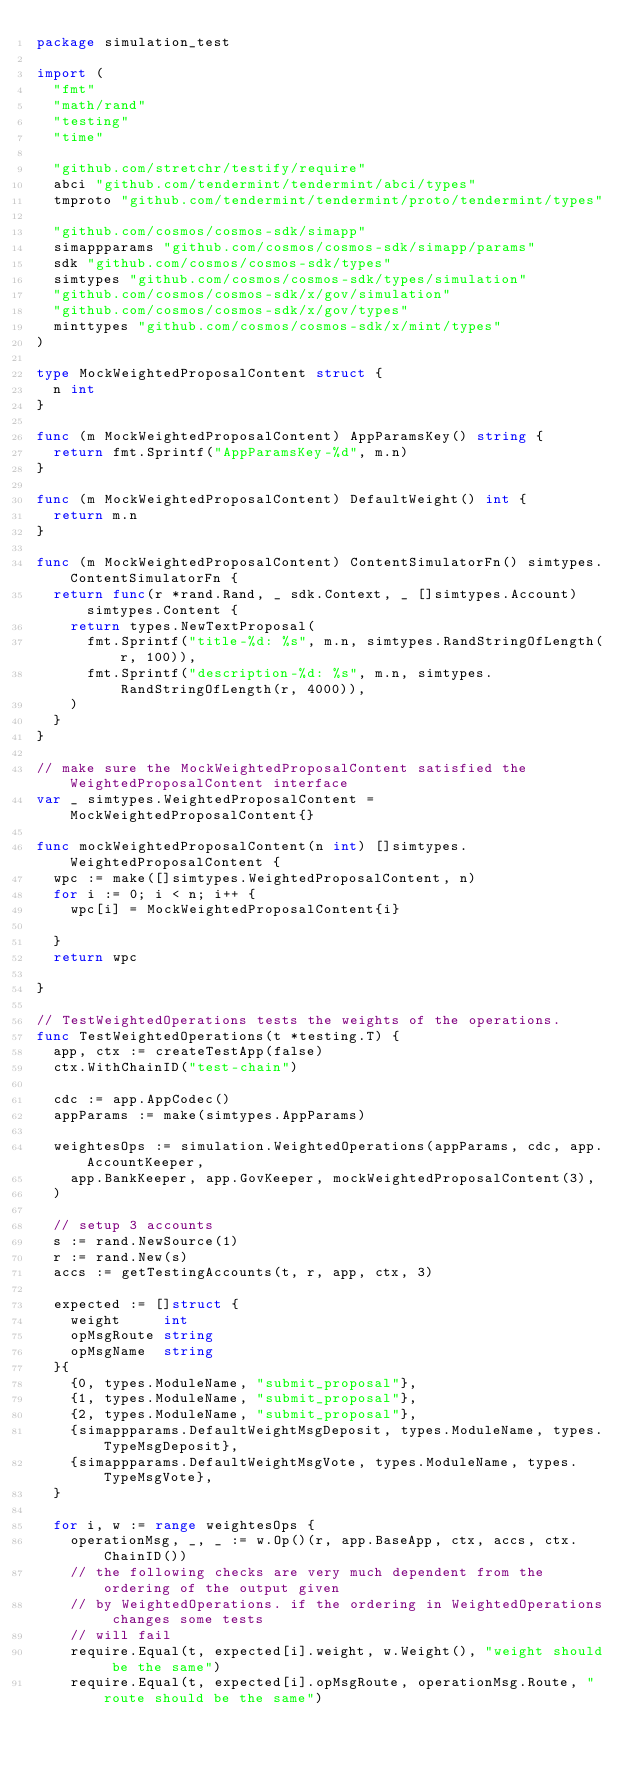<code> <loc_0><loc_0><loc_500><loc_500><_Go_>package simulation_test

import (
	"fmt"
	"math/rand"
	"testing"
	"time"

	"github.com/stretchr/testify/require"
	abci "github.com/tendermint/tendermint/abci/types"
	tmproto "github.com/tendermint/tendermint/proto/tendermint/types"

	"github.com/cosmos/cosmos-sdk/simapp"
	simappparams "github.com/cosmos/cosmos-sdk/simapp/params"
	sdk "github.com/cosmos/cosmos-sdk/types"
	simtypes "github.com/cosmos/cosmos-sdk/types/simulation"
	"github.com/cosmos/cosmos-sdk/x/gov/simulation"
	"github.com/cosmos/cosmos-sdk/x/gov/types"
	minttypes "github.com/cosmos/cosmos-sdk/x/mint/types"
)

type MockWeightedProposalContent struct {
	n int
}

func (m MockWeightedProposalContent) AppParamsKey() string {
	return fmt.Sprintf("AppParamsKey-%d", m.n)
}

func (m MockWeightedProposalContent) DefaultWeight() int {
	return m.n
}

func (m MockWeightedProposalContent) ContentSimulatorFn() simtypes.ContentSimulatorFn {
	return func(r *rand.Rand, _ sdk.Context, _ []simtypes.Account) simtypes.Content {
		return types.NewTextProposal(
			fmt.Sprintf("title-%d: %s", m.n, simtypes.RandStringOfLength(r, 100)),
			fmt.Sprintf("description-%d: %s", m.n, simtypes.RandStringOfLength(r, 4000)),
		)
	}
}

// make sure the MockWeightedProposalContent satisfied the WeightedProposalContent interface
var _ simtypes.WeightedProposalContent = MockWeightedProposalContent{}

func mockWeightedProposalContent(n int) []simtypes.WeightedProposalContent {
	wpc := make([]simtypes.WeightedProposalContent, n)
	for i := 0; i < n; i++ {
		wpc[i] = MockWeightedProposalContent{i}

	}
	return wpc

}

// TestWeightedOperations tests the weights of the operations.
func TestWeightedOperations(t *testing.T) {
	app, ctx := createTestApp(false)
	ctx.WithChainID("test-chain")

	cdc := app.AppCodec()
	appParams := make(simtypes.AppParams)

	weightesOps := simulation.WeightedOperations(appParams, cdc, app.AccountKeeper,
		app.BankKeeper, app.GovKeeper, mockWeightedProposalContent(3),
	)

	// setup 3 accounts
	s := rand.NewSource(1)
	r := rand.New(s)
	accs := getTestingAccounts(t, r, app, ctx, 3)

	expected := []struct {
		weight     int
		opMsgRoute string
		opMsgName  string
	}{
		{0, types.ModuleName, "submit_proposal"},
		{1, types.ModuleName, "submit_proposal"},
		{2, types.ModuleName, "submit_proposal"},
		{simappparams.DefaultWeightMsgDeposit, types.ModuleName, types.TypeMsgDeposit},
		{simappparams.DefaultWeightMsgVote, types.ModuleName, types.TypeMsgVote},
	}

	for i, w := range weightesOps {
		operationMsg, _, _ := w.Op()(r, app.BaseApp, ctx, accs, ctx.ChainID())
		// the following checks are very much dependent from the ordering of the output given
		// by WeightedOperations. if the ordering in WeightedOperations changes some tests
		// will fail
		require.Equal(t, expected[i].weight, w.Weight(), "weight should be the same")
		require.Equal(t, expected[i].opMsgRoute, operationMsg.Route, "route should be the same")</code> 